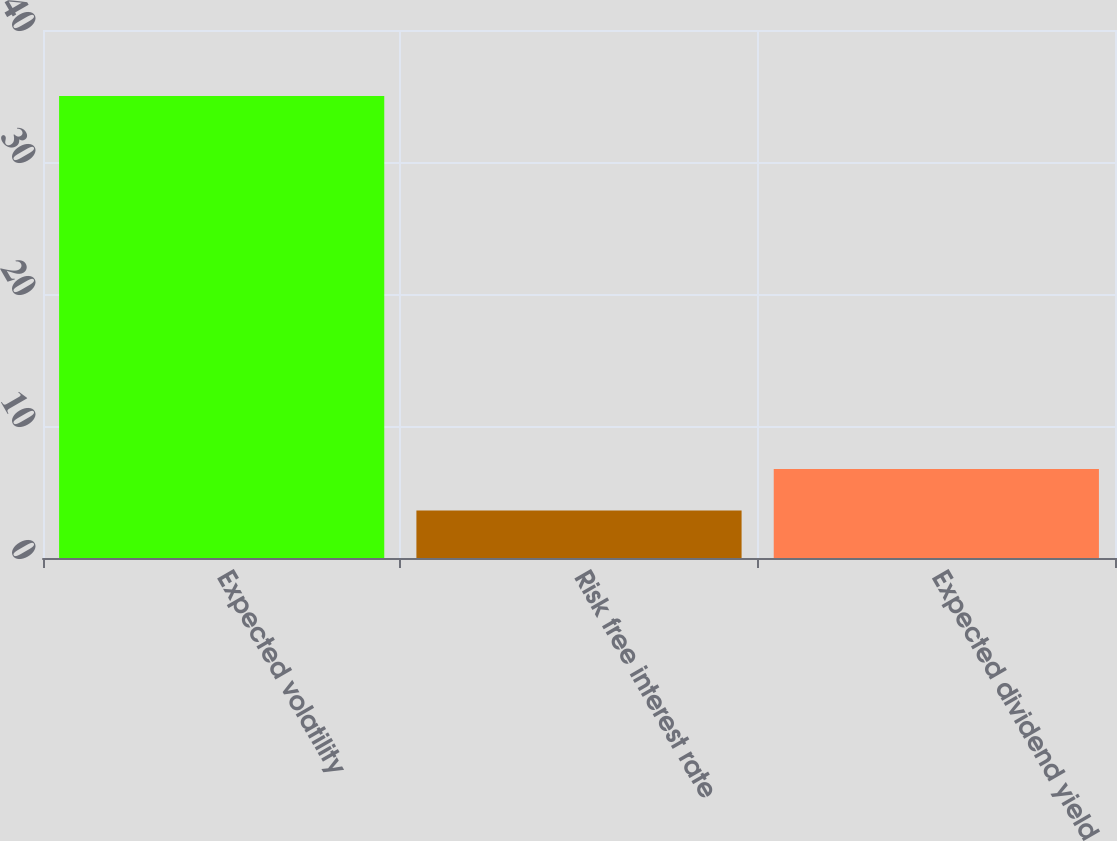Convert chart to OTSL. <chart><loc_0><loc_0><loc_500><loc_500><bar_chart><fcel>Expected volatility<fcel>Risk free interest rate<fcel>Expected dividend yield<nl><fcel>35<fcel>3.6<fcel>6.74<nl></chart> 